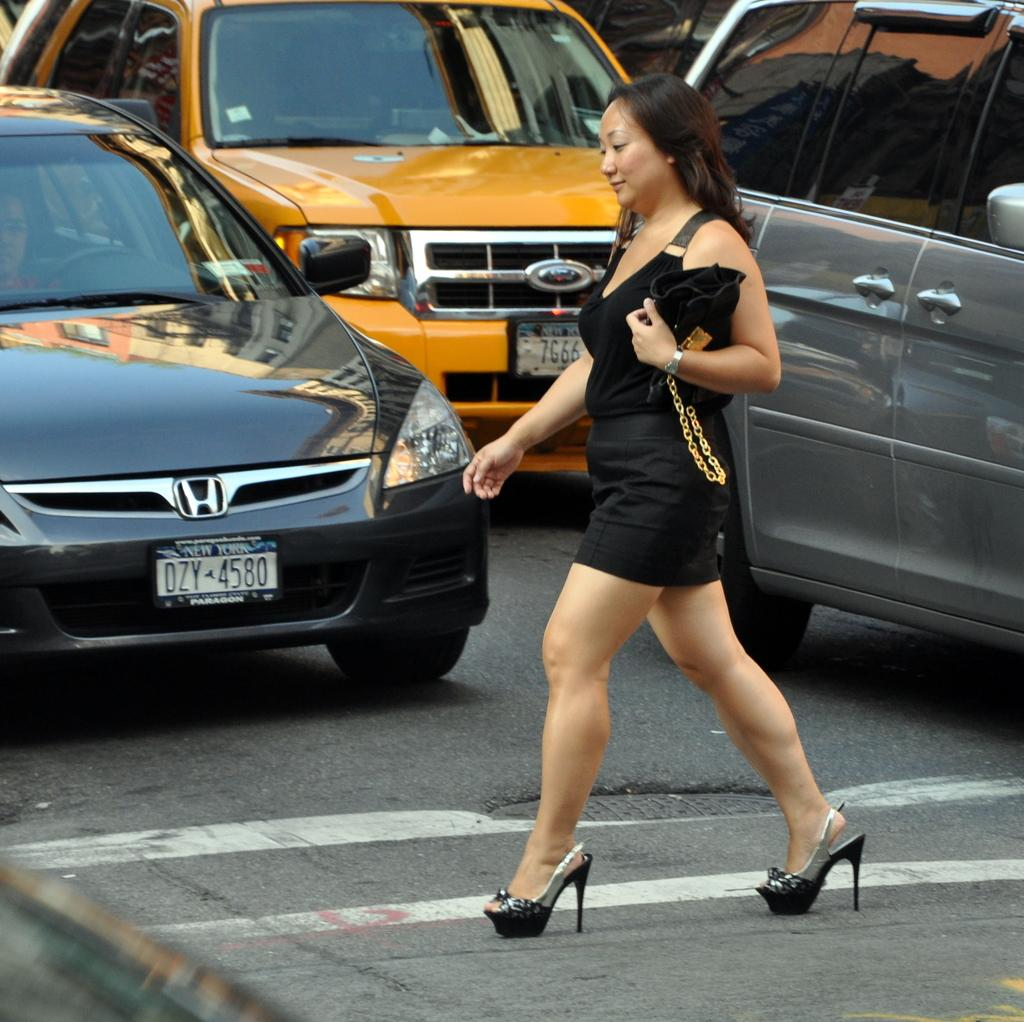<image>
Give a short and clear explanation of the subsequent image. A woman walks in a crosswalk in front of a car with NewYork plates. 